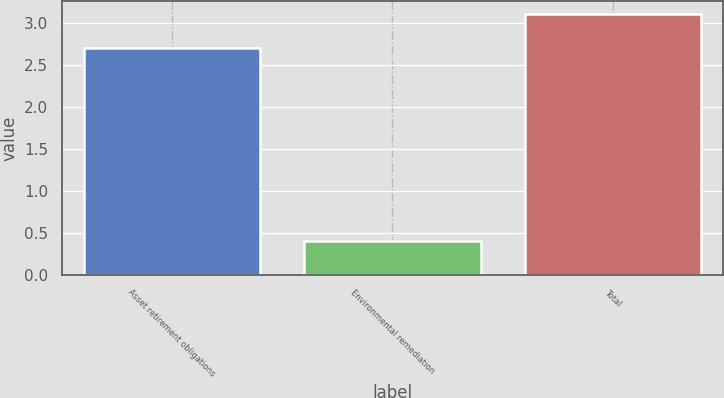<chart> <loc_0><loc_0><loc_500><loc_500><bar_chart><fcel>Asset retirement obligations<fcel>Environmental remediation<fcel>Total<nl><fcel>2.7<fcel>0.4<fcel>3.1<nl></chart> 